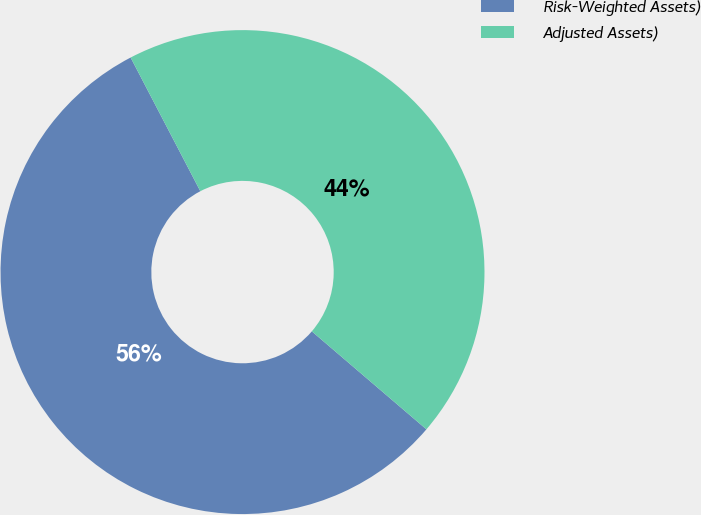Convert chart to OTSL. <chart><loc_0><loc_0><loc_500><loc_500><pie_chart><fcel>Risk-Weighted Assets)<fcel>Adjusted Assets)<nl><fcel>56.09%<fcel>43.91%<nl></chart> 